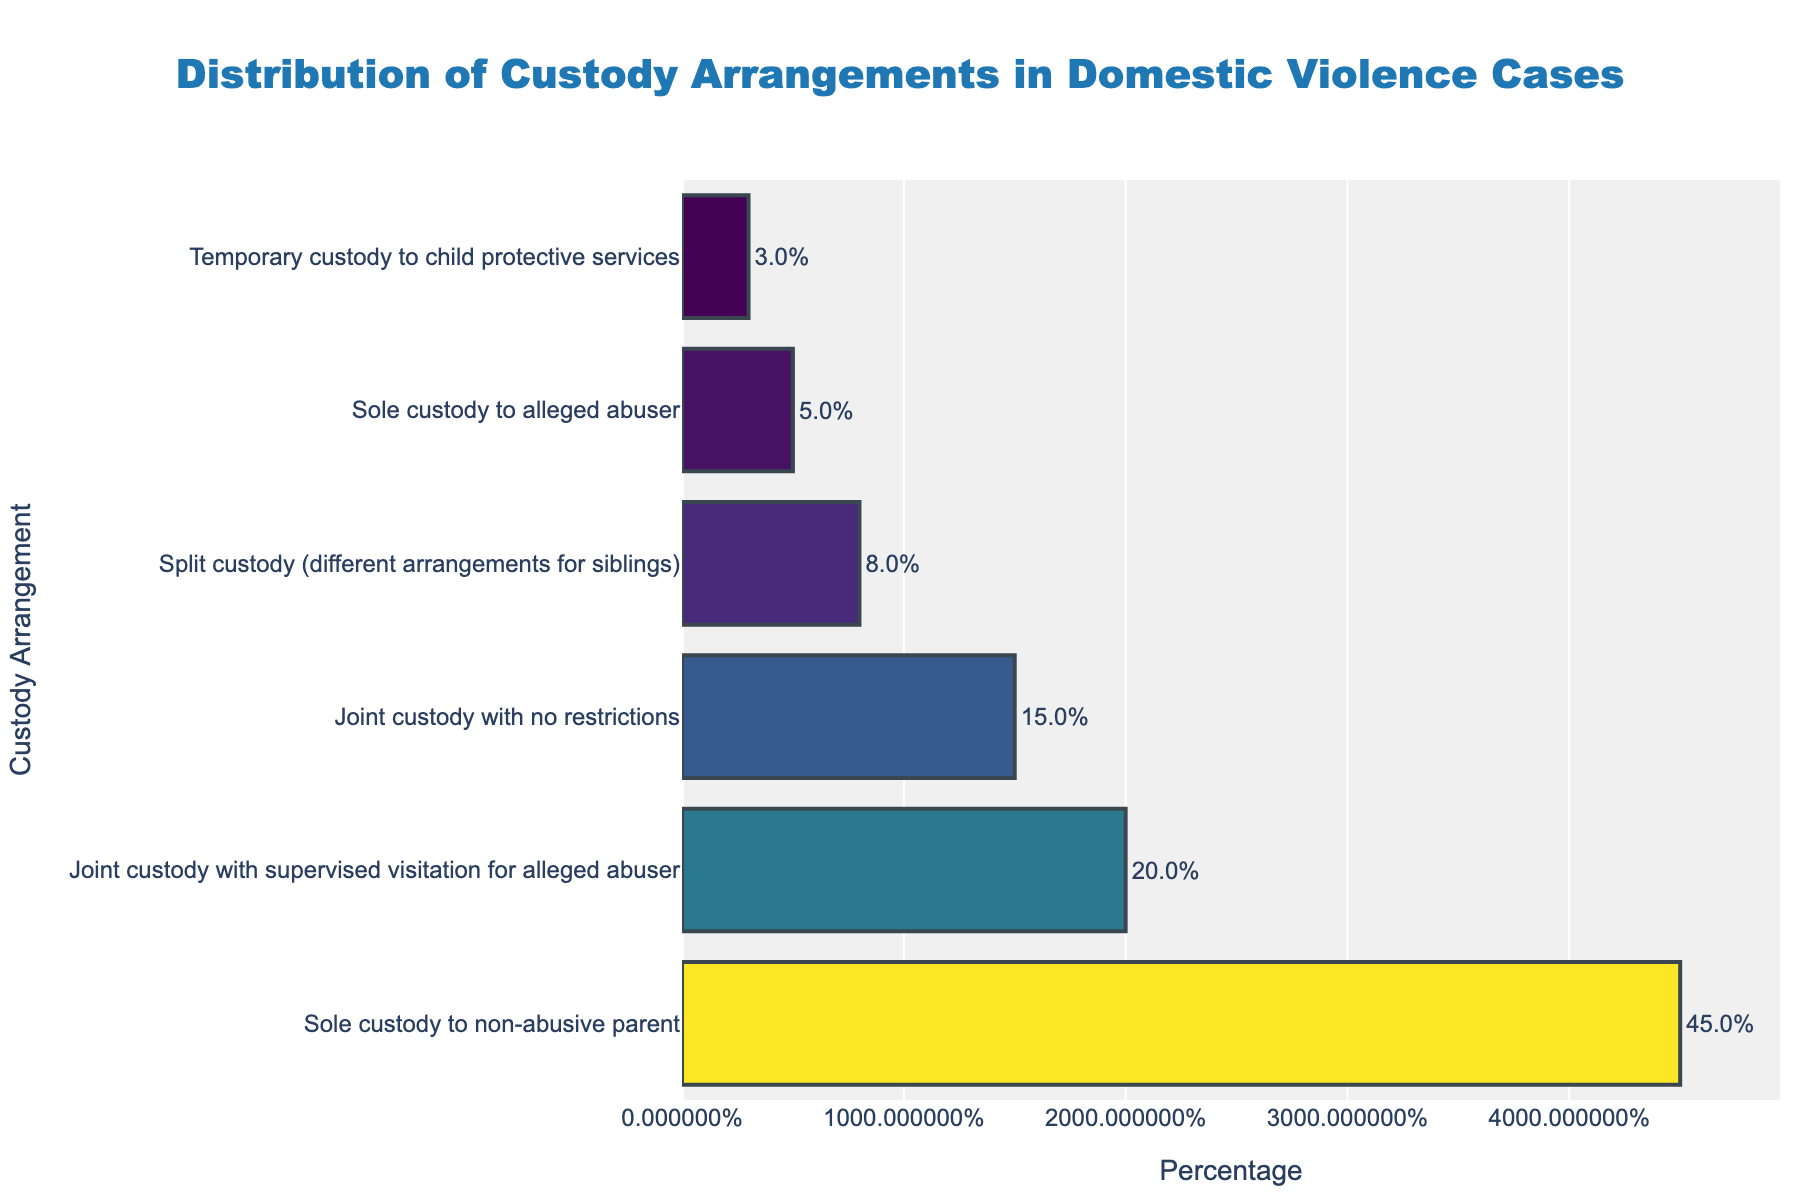Which custody arrangement has the highest percentage? The bar chart shows the percentage of different custody arrangements, with the top bar representing the highest percentage. The top bar is "Sole custody to non-abusive parent" with a percentage of 45%.
Answer: Sole custody to non-abusive parent What is the combined percentage of joint custody arrangements? To find the combined percentage of joint custody arrangements, sum the percentages of "Joint custody with supervised visitation for alleged abuser" (20%) and "Joint custody with no restrictions" (15%). 20% + 15% = 35%.
Answer: 35% How many times more common is sole custody to non-abusive parent compared to sole custody to alleged abuser? Divide the percentage of "Sole custody to non-abusive parent" (45%) by the percentage of "Sole custody to alleged abuser" (5%). 45% / 5% = 9.
Answer: 9 times Which custody arrangement has the least percentage, and what is it? The bar chart shows different custody arrangements in descending order of percentage. The smallest bar represents the least percentage, which is "Temporary custody to child protective services" at 3%.
Answer: Temporary custody to child protective services, 3% What is the difference in percentage between joint custody with supervised visits and joint custody with no restrictions? Subtract the percentage of "Joint custody with no restrictions" (15%) from the percentage of "Joint custody with supervised visitation for alleged abuser" (20%). 20% - 15% = 5%.
Answer: 5% How do split custody arrangements compare to joint custody arrangements in terms of percentage? The percentage for "Split custody" is 8%, and the combined percentage for joint custody arrangements is 35%. Split custody is less common than joint custody arrangements. 8% compared to 35%.
Answer: Less common What are the percentages of custody arrangements that involve some form of joint custody? The chart indicates that "Joint custody with supervised visitation for alleged abuser" has 20% and "Joint custody with no restrictions" has 15%. Adding these gives: 20% + 15% = 35%.
Answer: 35% By what percentage does sole custody to the non-abusive parent exceed the second most common arrangement? Subtract the percentage of "Joint custody with supervised visitation for alleged abuser" (20%) from "Sole custody to non-abusive parent" (45%). 45% - 20% = 25%.
Answer: 25% If we were to combine all forms of sole and split custody arrangements, what would be the total percentage? Add the percentages of "Sole custody to non-abusive parent" (45%), "Sole custody to alleged abuser" (5%), and "Split custody" (8%). 45% + 5% + 8% = 58%.
Answer: 58% What would be the average percentage of custody arrangements listed in the chart? Sum the percentages of all listed custody arrangements: 45% + 20% + 15% + 5% + 8% + 3% = 96%. Divide by the number of arrangements (6). 96% / 6 ≈ 16%.
Answer: 16% 